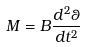<formula> <loc_0><loc_0><loc_500><loc_500>M = B \frac { d ^ { 2 } \theta } { d t ^ { 2 } }</formula> 